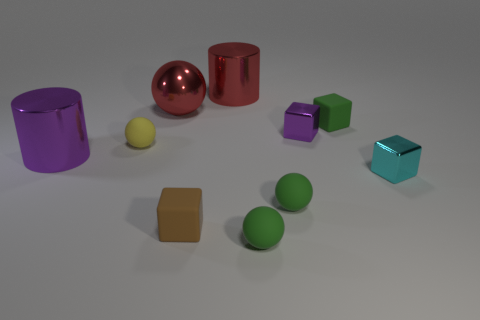How many small blocks are there?
Your response must be concise. 4. The ball that is behind the tiny rubber cube that is right of the small purple block is made of what material?
Your answer should be very brief. Metal. There is a purple object that is the same size as the metallic sphere; what is its material?
Give a very brief answer. Metal. There is a metallic cylinder behind the purple block; is its size the same as the purple shiny cylinder?
Offer a terse response. Yes. Is the shape of the small green object behind the tiny purple metal block the same as  the small yellow thing?
Provide a short and direct response. No. How many things are brown rubber objects or rubber things that are in front of the tiny yellow matte sphere?
Offer a very short reply. 3. Are there fewer large brown spheres than metallic objects?
Offer a terse response. Yes. Is the number of cyan shiny objects greater than the number of big gray metal things?
Provide a short and direct response. Yes. What number of other things are there of the same material as the tiny yellow sphere
Your answer should be compact. 4. What number of small rubber objects are in front of the cyan shiny block that is right of the red metallic object that is on the right side of the big metallic ball?
Make the answer very short. 3. 